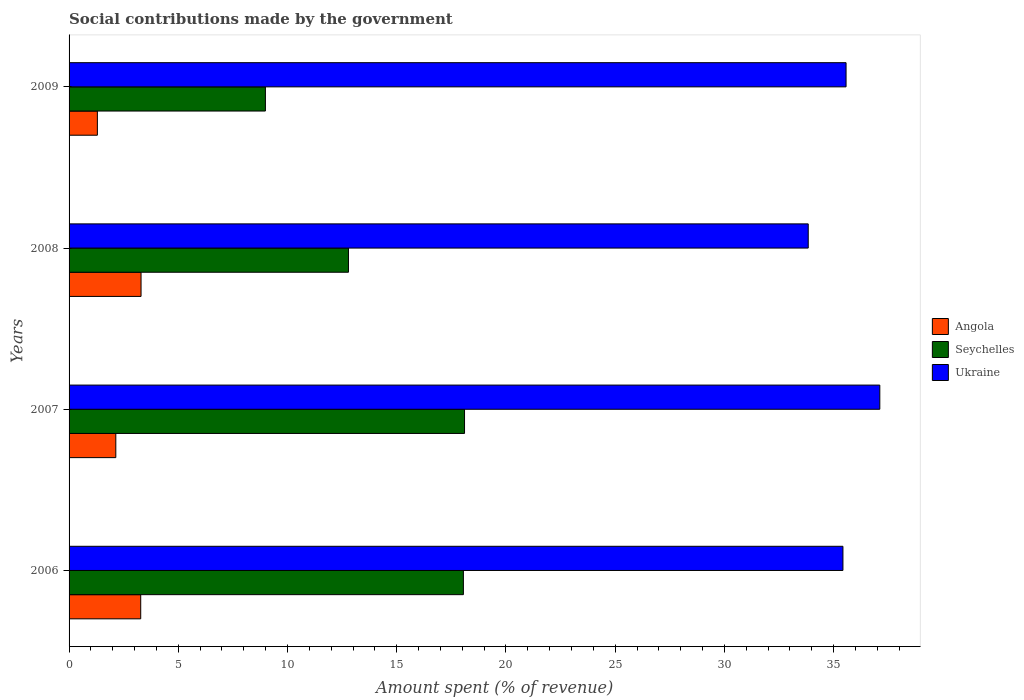How many different coloured bars are there?
Make the answer very short. 3. How many bars are there on the 1st tick from the top?
Make the answer very short. 3. How many bars are there on the 2nd tick from the bottom?
Your response must be concise. 3. What is the label of the 3rd group of bars from the top?
Offer a very short reply. 2007. What is the amount spent (in %) on social contributions in Seychelles in 2008?
Your response must be concise. 12.79. Across all years, what is the maximum amount spent (in %) on social contributions in Angola?
Provide a short and direct response. 3.29. Across all years, what is the minimum amount spent (in %) on social contributions in Ukraine?
Provide a succinct answer. 33.84. What is the total amount spent (in %) on social contributions in Seychelles in the graph?
Provide a succinct answer. 57.94. What is the difference between the amount spent (in %) on social contributions in Angola in 2007 and that in 2009?
Provide a succinct answer. 0.84. What is the difference between the amount spent (in %) on social contributions in Angola in 2008 and the amount spent (in %) on social contributions in Seychelles in 2007?
Provide a short and direct response. -14.81. What is the average amount spent (in %) on social contributions in Angola per year?
Ensure brevity in your answer.  2.5. In the year 2006, what is the difference between the amount spent (in %) on social contributions in Ukraine and amount spent (in %) on social contributions in Seychelles?
Offer a terse response. 17.38. What is the ratio of the amount spent (in %) on social contributions in Seychelles in 2006 to that in 2009?
Ensure brevity in your answer.  2.01. Is the difference between the amount spent (in %) on social contributions in Ukraine in 2007 and 2008 greater than the difference between the amount spent (in %) on social contributions in Seychelles in 2007 and 2008?
Offer a very short reply. No. What is the difference between the highest and the second highest amount spent (in %) on social contributions in Ukraine?
Make the answer very short. 1.55. What is the difference between the highest and the lowest amount spent (in %) on social contributions in Seychelles?
Your answer should be very brief. 9.12. In how many years, is the amount spent (in %) on social contributions in Ukraine greater than the average amount spent (in %) on social contributions in Ukraine taken over all years?
Provide a succinct answer. 2. Is the sum of the amount spent (in %) on social contributions in Ukraine in 2006 and 2008 greater than the maximum amount spent (in %) on social contributions in Angola across all years?
Make the answer very short. Yes. What does the 2nd bar from the top in 2009 represents?
Your answer should be very brief. Seychelles. What does the 2nd bar from the bottom in 2006 represents?
Give a very brief answer. Seychelles. How many bars are there?
Provide a succinct answer. 12. Are all the bars in the graph horizontal?
Ensure brevity in your answer.  Yes. Are the values on the major ticks of X-axis written in scientific E-notation?
Your answer should be compact. No. How are the legend labels stacked?
Your answer should be very brief. Vertical. What is the title of the graph?
Ensure brevity in your answer.  Social contributions made by the government. What is the label or title of the X-axis?
Keep it short and to the point. Amount spent (% of revenue). What is the Amount spent (% of revenue) in Angola in 2006?
Your answer should be compact. 3.28. What is the Amount spent (% of revenue) of Seychelles in 2006?
Offer a terse response. 18.05. What is the Amount spent (% of revenue) in Ukraine in 2006?
Your response must be concise. 35.43. What is the Amount spent (% of revenue) of Angola in 2007?
Offer a very short reply. 2.14. What is the Amount spent (% of revenue) in Seychelles in 2007?
Your answer should be very brief. 18.1. What is the Amount spent (% of revenue) in Ukraine in 2007?
Your response must be concise. 37.12. What is the Amount spent (% of revenue) in Angola in 2008?
Offer a terse response. 3.29. What is the Amount spent (% of revenue) of Seychelles in 2008?
Your answer should be compact. 12.79. What is the Amount spent (% of revenue) in Ukraine in 2008?
Keep it short and to the point. 33.84. What is the Amount spent (% of revenue) in Angola in 2009?
Make the answer very short. 1.3. What is the Amount spent (% of revenue) in Seychelles in 2009?
Keep it short and to the point. 8.99. What is the Amount spent (% of revenue) of Ukraine in 2009?
Make the answer very short. 35.57. Across all years, what is the maximum Amount spent (% of revenue) of Angola?
Your response must be concise. 3.29. Across all years, what is the maximum Amount spent (% of revenue) of Seychelles?
Keep it short and to the point. 18.1. Across all years, what is the maximum Amount spent (% of revenue) in Ukraine?
Give a very brief answer. 37.12. Across all years, what is the minimum Amount spent (% of revenue) of Angola?
Provide a succinct answer. 1.3. Across all years, what is the minimum Amount spent (% of revenue) of Seychelles?
Your answer should be very brief. 8.99. Across all years, what is the minimum Amount spent (% of revenue) of Ukraine?
Provide a succinct answer. 33.84. What is the total Amount spent (% of revenue) in Angola in the graph?
Your response must be concise. 10.01. What is the total Amount spent (% of revenue) of Seychelles in the graph?
Keep it short and to the point. 57.94. What is the total Amount spent (% of revenue) in Ukraine in the graph?
Ensure brevity in your answer.  141.95. What is the difference between the Amount spent (% of revenue) in Angola in 2006 and that in 2007?
Offer a terse response. 1.14. What is the difference between the Amount spent (% of revenue) of Seychelles in 2006 and that in 2007?
Provide a succinct answer. -0.05. What is the difference between the Amount spent (% of revenue) in Ukraine in 2006 and that in 2007?
Make the answer very short. -1.69. What is the difference between the Amount spent (% of revenue) in Angola in 2006 and that in 2008?
Your answer should be compact. -0.01. What is the difference between the Amount spent (% of revenue) in Seychelles in 2006 and that in 2008?
Keep it short and to the point. 5.26. What is the difference between the Amount spent (% of revenue) in Ukraine in 2006 and that in 2008?
Your answer should be very brief. 1.59. What is the difference between the Amount spent (% of revenue) of Angola in 2006 and that in 2009?
Your answer should be compact. 1.98. What is the difference between the Amount spent (% of revenue) of Seychelles in 2006 and that in 2009?
Your answer should be compact. 9.06. What is the difference between the Amount spent (% of revenue) in Ukraine in 2006 and that in 2009?
Provide a succinct answer. -0.14. What is the difference between the Amount spent (% of revenue) of Angola in 2007 and that in 2008?
Ensure brevity in your answer.  -1.16. What is the difference between the Amount spent (% of revenue) in Seychelles in 2007 and that in 2008?
Provide a short and direct response. 5.31. What is the difference between the Amount spent (% of revenue) in Ukraine in 2007 and that in 2008?
Offer a terse response. 3.28. What is the difference between the Amount spent (% of revenue) in Angola in 2007 and that in 2009?
Make the answer very short. 0.84. What is the difference between the Amount spent (% of revenue) in Seychelles in 2007 and that in 2009?
Your response must be concise. 9.12. What is the difference between the Amount spent (% of revenue) in Ukraine in 2007 and that in 2009?
Offer a very short reply. 1.55. What is the difference between the Amount spent (% of revenue) in Angola in 2008 and that in 2009?
Your answer should be very brief. 2. What is the difference between the Amount spent (% of revenue) in Seychelles in 2008 and that in 2009?
Offer a very short reply. 3.8. What is the difference between the Amount spent (% of revenue) of Ukraine in 2008 and that in 2009?
Provide a short and direct response. -1.73. What is the difference between the Amount spent (% of revenue) in Angola in 2006 and the Amount spent (% of revenue) in Seychelles in 2007?
Ensure brevity in your answer.  -14.82. What is the difference between the Amount spent (% of revenue) in Angola in 2006 and the Amount spent (% of revenue) in Ukraine in 2007?
Offer a very short reply. -33.84. What is the difference between the Amount spent (% of revenue) of Seychelles in 2006 and the Amount spent (% of revenue) of Ukraine in 2007?
Ensure brevity in your answer.  -19.06. What is the difference between the Amount spent (% of revenue) of Angola in 2006 and the Amount spent (% of revenue) of Seychelles in 2008?
Offer a very short reply. -9.51. What is the difference between the Amount spent (% of revenue) in Angola in 2006 and the Amount spent (% of revenue) in Ukraine in 2008?
Offer a very short reply. -30.56. What is the difference between the Amount spent (% of revenue) of Seychelles in 2006 and the Amount spent (% of revenue) of Ukraine in 2008?
Offer a terse response. -15.79. What is the difference between the Amount spent (% of revenue) in Angola in 2006 and the Amount spent (% of revenue) in Seychelles in 2009?
Your answer should be compact. -5.71. What is the difference between the Amount spent (% of revenue) in Angola in 2006 and the Amount spent (% of revenue) in Ukraine in 2009?
Make the answer very short. -32.29. What is the difference between the Amount spent (% of revenue) in Seychelles in 2006 and the Amount spent (% of revenue) in Ukraine in 2009?
Ensure brevity in your answer.  -17.52. What is the difference between the Amount spent (% of revenue) in Angola in 2007 and the Amount spent (% of revenue) in Seychelles in 2008?
Ensure brevity in your answer.  -10.65. What is the difference between the Amount spent (% of revenue) in Angola in 2007 and the Amount spent (% of revenue) in Ukraine in 2008?
Give a very brief answer. -31.7. What is the difference between the Amount spent (% of revenue) in Seychelles in 2007 and the Amount spent (% of revenue) in Ukraine in 2008?
Offer a terse response. -15.73. What is the difference between the Amount spent (% of revenue) in Angola in 2007 and the Amount spent (% of revenue) in Seychelles in 2009?
Offer a very short reply. -6.85. What is the difference between the Amount spent (% of revenue) of Angola in 2007 and the Amount spent (% of revenue) of Ukraine in 2009?
Provide a succinct answer. -33.43. What is the difference between the Amount spent (% of revenue) in Seychelles in 2007 and the Amount spent (% of revenue) in Ukraine in 2009?
Make the answer very short. -17.47. What is the difference between the Amount spent (% of revenue) of Angola in 2008 and the Amount spent (% of revenue) of Seychelles in 2009?
Your answer should be very brief. -5.69. What is the difference between the Amount spent (% of revenue) of Angola in 2008 and the Amount spent (% of revenue) of Ukraine in 2009?
Provide a succinct answer. -32.28. What is the difference between the Amount spent (% of revenue) in Seychelles in 2008 and the Amount spent (% of revenue) in Ukraine in 2009?
Offer a very short reply. -22.78. What is the average Amount spent (% of revenue) in Angola per year?
Offer a very short reply. 2.5. What is the average Amount spent (% of revenue) in Seychelles per year?
Your answer should be compact. 14.48. What is the average Amount spent (% of revenue) of Ukraine per year?
Your answer should be very brief. 35.49. In the year 2006, what is the difference between the Amount spent (% of revenue) of Angola and Amount spent (% of revenue) of Seychelles?
Provide a short and direct response. -14.77. In the year 2006, what is the difference between the Amount spent (% of revenue) of Angola and Amount spent (% of revenue) of Ukraine?
Your answer should be very brief. -32.15. In the year 2006, what is the difference between the Amount spent (% of revenue) in Seychelles and Amount spent (% of revenue) in Ukraine?
Your answer should be very brief. -17.38. In the year 2007, what is the difference between the Amount spent (% of revenue) of Angola and Amount spent (% of revenue) of Seychelles?
Offer a very short reply. -15.96. In the year 2007, what is the difference between the Amount spent (% of revenue) in Angola and Amount spent (% of revenue) in Ukraine?
Provide a short and direct response. -34.98. In the year 2007, what is the difference between the Amount spent (% of revenue) in Seychelles and Amount spent (% of revenue) in Ukraine?
Offer a terse response. -19.01. In the year 2008, what is the difference between the Amount spent (% of revenue) of Angola and Amount spent (% of revenue) of Seychelles?
Give a very brief answer. -9.5. In the year 2008, what is the difference between the Amount spent (% of revenue) of Angola and Amount spent (% of revenue) of Ukraine?
Your response must be concise. -30.54. In the year 2008, what is the difference between the Amount spent (% of revenue) in Seychelles and Amount spent (% of revenue) in Ukraine?
Your answer should be very brief. -21.05. In the year 2009, what is the difference between the Amount spent (% of revenue) in Angola and Amount spent (% of revenue) in Seychelles?
Offer a very short reply. -7.69. In the year 2009, what is the difference between the Amount spent (% of revenue) of Angola and Amount spent (% of revenue) of Ukraine?
Offer a terse response. -34.28. In the year 2009, what is the difference between the Amount spent (% of revenue) of Seychelles and Amount spent (% of revenue) of Ukraine?
Your response must be concise. -26.58. What is the ratio of the Amount spent (% of revenue) of Angola in 2006 to that in 2007?
Your answer should be compact. 1.53. What is the ratio of the Amount spent (% of revenue) of Ukraine in 2006 to that in 2007?
Provide a short and direct response. 0.95. What is the ratio of the Amount spent (% of revenue) of Seychelles in 2006 to that in 2008?
Provide a succinct answer. 1.41. What is the ratio of the Amount spent (% of revenue) of Ukraine in 2006 to that in 2008?
Give a very brief answer. 1.05. What is the ratio of the Amount spent (% of revenue) in Angola in 2006 to that in 2009?
Your response must be concise. 2.53. What is the ratio of the Amount spent (% of revenue) of Seychelles in 2006 to that in 2009?
Offer a terse response. 2.01. What is the ratio of the Amount spent (% of revenue) of Ukraine in 2006 to that in 2009?
Provide a short and direct response. 1. What is the ratio of the Amount spent (% of revenue) in Angola in 2007 to that in 2008?
Provide a succinct answer. 0.65. What is the ratio of the Amount spent (% of revenue) of Seychelles in 2007 to that in 2008?
Your answer should be compact. 1.42. What is the ratio of the Amount spent (% of revenue) in Ukraine in 2007 to that in 2008?
Your response must be concise. 1.1. What is the ratio of the Amount spent (% of revenue) of Angola in 2007 to that in 2009?
Ensure brevity in your answer.  1.65. What is the ratio of the Amount spent (% of revenue) in Seychelles in 2007 to that in 2009?
Make the answer very short. 2.01. What is the ratio of the Amount spent (% of revenue) in Ukraine in 2007 to that in 2009?
Your answer should be compact. 1.04. What is the ratio of the Amount spent (% of revenue) of Angola in 2008 to that in 2009?
Keep it short and to the point. 2.54. What is the ratio of the Amount spent (% of revenue) of Seychelles in 2008 to that in 2009?
Offer a very short reply. 1.42. What is the ratio of the Amount spent (% of revenue) of Ukraine in 2008 to that in 2009?
Your answer should be very brief. 0.95. What is the difference between the highest and the second highest Amount spent (% of revenue) in Angola?
Provide a succinct answer. 0.01. What is the difference between the highest and the second highest Amount spent (% of revenue) in Seychelles?
Provide a short and direct response. 0.05. What is the difference between the highest and the second highest Amount spent (% of revenue) of Ukraine?
Keep it short and to the point. 1.55. What is the difference between the highest and the lowest Amount spent (% of revenue) in Angola?
Keep it short and to the point. 2. What is the difference between the highest and the lowest Amount spent (% of revenue) of Seychelles?
Your answer should be compact. 9.12. What is the difference between the highest and the lowest Amount spent (% of revenue) of Ukraine?
Make the answer very short. 3.28. 